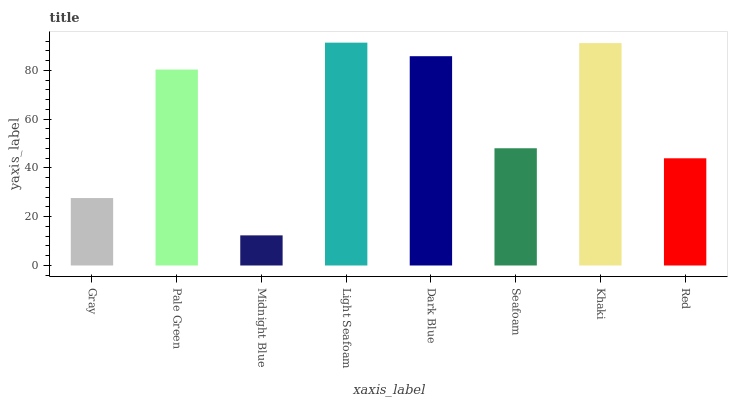Is Midnight Blue the minimum?
Answer yes or no. Yes. Is Light Seafoam the maximum?
Answer yes or no. Yes. Is Pale Green the minimum?
Answer yes or no. No. Is Pale Green the maximum?
Answer yes or no. No. Is Pale Green greater than Gray?
Answer yes or no. Yes. Is Gray less than Pale Green?
Answer yes or no. Yes. Is Gray greater than Pale Green?
Answer yes or no. No. Is Pale Green less than Gray?
Answer yes or no. No. Is Pale Green the high median?
Answer yes or no. Yes. Is Seafoam the low median?
Answer yes or no. Yes. Is Red the high median?
Answer yes or no. No. Is Khaki the low median?
Answer yes or no. No. 